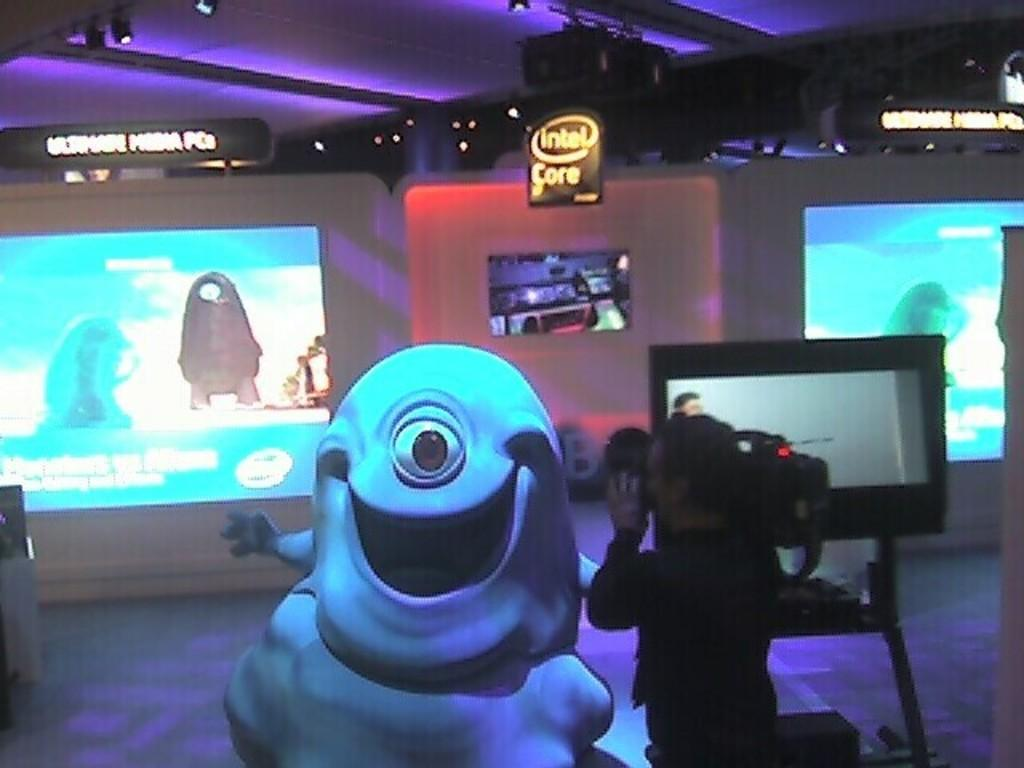<image>
Present a compact description of the photo's key features. an intel sign that is above the ground 